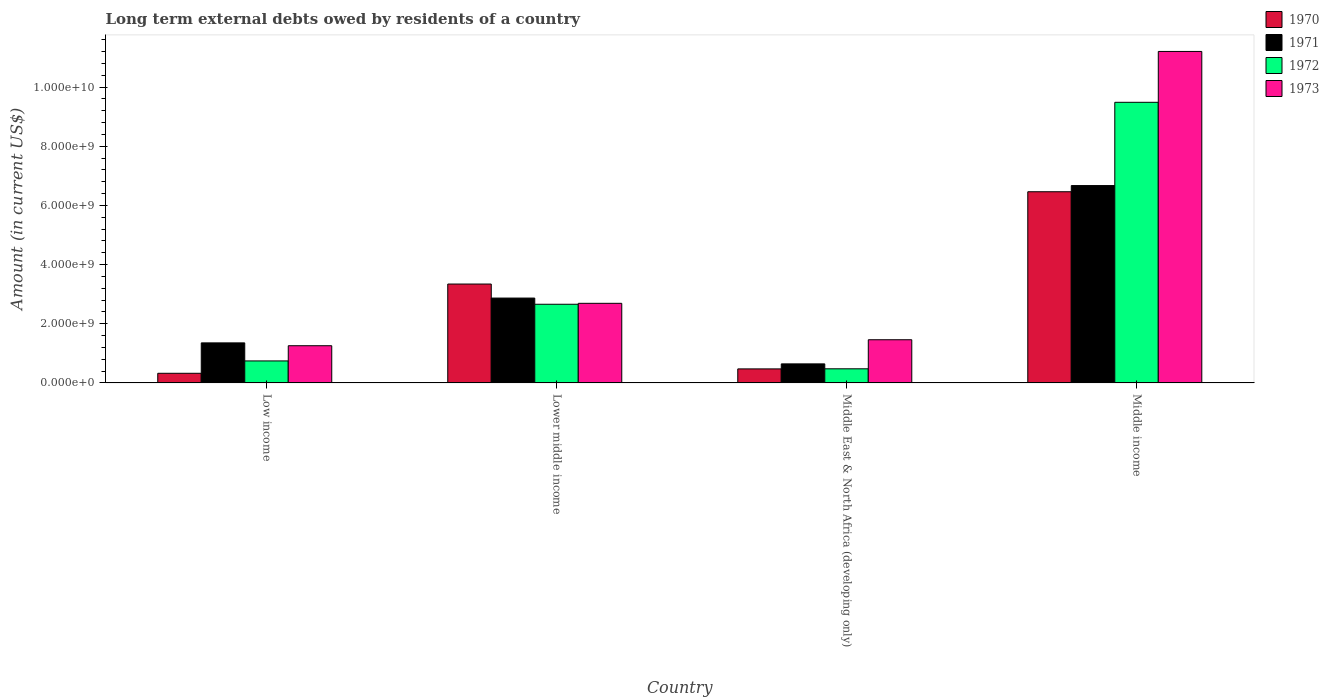Are the number of bars per tick equal to the number of legend labels?
Keep it short and to the point. Yes. Are the number of bars on each tick of the X-axis equal?
Keep it short and to the point. Yes. How many bars are there on the 4th tick from the left?
Make the answer very short. 4. How many bars are there on the 1st tick from the right?
Your answer should be compact. 4. What is the label of the 3rd group of bars from the left?
Ensure brevity in your answer.  Middle East & North Africa (developing only). What is the amount of long-term external debts owed by residents in 1970 in Middle East & North Africa (developing only)?
Provide a succinct answer. 4.75e+08. Across all countries, what is the maximum amount of long-term external debts owed by residents in 1970?
Your answer should be compact. 6.46e+09. Across all countries, what is the minimum amount of long-term external debts owed by residents in 1970?
Keep it short and to the point. 3.26e+08. In which country was the amount of long-term external debts owed by residents in 1970 maximum?
Your answer should be compact. Middle income. In which country was the amount of long-term external debts owed by residents in 1970 minimum?
Give a very brief answer. Low income. What is the total amount of long-term external debts owed by residents in 1972 in the graph?
Your answer should be compact. 1.34e+1. What is the difference between the amount of long-term external debts owed by residents in 1970 in Middle East & North Africa (developing only) and that in Middle income?
Offer a terse response. -5.99e+09. What is the difference between the amount of long-term external debts owed by residents in 1970 in Lower middle income and the amount of long-term external debts owed by residents in 1971 in Low income?
Give a very brief answer. 1.99e+09. What is the average amount of long-term external debts owed by residents in 1973 per country?
Offer a very short reply. 4.15e+09. What is the difference between the amount of long-term external debts owed by residents of/in 1973 and amount of long-term external debts owed by residents of/in 1971 in Low income?
Keep it short and to the point. -9.57e+07. What is the ratio of the amount of long-term external debts owed by residents in 1973 in Low income to that in Lower middle income?
Offer a terse response. 0.47. What is the difference between the highest and the second highest amount of long-term external debts owed by residents in 1972?
Your response must be concise. 6.82e+09. What is the difference between the highest and the lowest amount of long-term external debts owed by residents in 1973?
Make the answer very short. 9.94e+09. Is it the case that in every country, the sum of the amount of long-term external debts owed by residents in 1970 and amount of long-term external debts owed by residents in 1973 is greater than the sum of amount of long-term external debts owed by residents in 1972 and amount of long-term external debts owed by residents in 1971?
Offer a very short reply. No. What does the 2nd bar from the left in Middle income represents?
Provide a short and direct response. 1971. What does the 2nd bar from the right in Middle income represents?
Your answer should be compact. 1972. Does the graph contain grids?
Ensure brevity in your answer.  No. How are the legend labels stacked?
Provide a short and direct response. Vertical. What is the title of the graph?
Make the answer very short. Long term external debts owed by residents of a country. What is the Amount (in current US$) of 1970 in Low income?
Your answer should be very brief. 3.26e+08. What is the Amount (in current US$) in 1971 in Low income?
Keep it short and to the point. 1.35e+09. What is the Amount (in current US$) in 1972 in Low income?
Make the answer very short. 7.44e+08. What is the Amount (in current US$) in 1973 in Low income?
Ensure brevity in your answer.  1.26e+09. What is the Amount (in current US$) in 1970 in Lower middle income?
Offer a terse response. 3.34e+09. What is the Amount (in current US$) in 1971 in Lower middle income?
Your answer should be compact. 2.87e+09. What is the Amount (in current US$) in 1972 in Lower middle income?
Your answer should be compact. 2.66e+09. What is the Amount (in current US$) in 1973 in Lower middle income?
Your answer should be compact. 2.69e+09. What is the Amount (in current US$) in 1970 in Middle East & North Africa (developing only)?
Provide a succinct answer. 4.75e+08. What is the Amount (in current US$) in 1971 in Middle East & North Africa (developing only)?
Give a very brief answer. 6.44e+08. What is the Amount (in current US$) in 1972 in Middle East & North Africa (developing only)?
Your answer should be compact. 4.78e+08. What is the Amount (in current US$) of 1973 in Middle East & North Africa (developing only)?
Give a very brief answer. 1.46e+09. What is the Amount (in current US$) of 1970 in Middle income?
Provide a succinct answer. 6.46e+09. What is the Amount (in current US$) in 1971 in Middle income?
Keep it short and to the point. 6.67e+09. What is the Amount (in current US$) of 1972 in Middle income?
Offer a very short reply. 9.48e+09. What is the Amount (in current US$) in 1973 in Middle income?
Your answer should be very brief. 1.12e+1. Across all countries, what is the maximum Amount (in current US$) of 1970?
Offer a very short reply. 6.46e+09. Across all countries, what is the maximum Amount (in current US$) in 1971?
Your response must be concise. 6.67e+09. Across all countries, what is the maximum Amount (in current US$) of 1972?
Your answer should be compact. 9.48e+09. Across all countries, what is the maximum Amount (in current US$) in 1973?
Make the answer very short. 1.12e+1. Across all countries, what is the minimum Amount (in current US$) of 1970?
Give a very brief answer. 3.26e+08. Across all countries, what is the minimum Amount (in current US$) in 1971?
Offer a very short reply. 6.44e+08. Across all countries, what is the minimum Amount (in current US$) of 1972?
Ensure brevity in your answer.  4.78e+08. Across all countries, what is the minimum Amount (in current US$) of 1973?
Make the answer very short. 1.26e+09. What is the total Amount (in current US$) in 1970 in the graph?
Make the answer very short. 1.06e+1. What is the total Amount (in current US$) of 1971 in the graph?
Provide a succinct answer. 1.15e+1. What is the total Amount (in current US$) of 1972 in the graph?
Provide a succinct answer. 1.34e+1. What is the total Amount (in current US$) of 1973 in the graph?
Provide a short and direct response. 1.66e+1. What is the difference between the Amount (in current US$) of 1970 in Low income and that in Lower middle income?
Offer a very short reply. -3.02e+09. What is the difference between the Amount (in current US$) in 1971 in Low income and that in Lower middle income?
Offer a very short reply. -1.51e+09. What is the difference between the Amount (in current US$) of 1972 in Low income and that in Lower middle income?
Ensure brevity in your answer.  -1.91e+09. What is the difference between the Amount (in current US$) of 1973 in Low income and that in Lower middle income?
Keep it short and to the point. -1.43e+09. What is the difference between the Amount (in current US$) in 1970 in Low income and that in Middle East & North Africa (developing only)?
Ensure brevity in your answer.  -1.48e+08. What is the difference between the Amount (in current US$) of 1971 in Low income and that in Middle East & North Africa (developing only)?
Offer a terse response. 7.09e+08. What is the difference between the Amount (in current US$) of 1972 in Low income and that in Middle East & North Africa (developing only)?
Offer a terse response. 2.66e+08. What is the difference between the Amount (in current US$) in 1973 in Low income and that in Middle East & North Africa (developing only)?
Provide a short and direct response. -2.02e+08. What is the difference between the Amount (in current US$) of 1970 in Low income and that in Middle income?
Keep it short and to the point. -6.13e+09. What is the difference between the Amount (in current US$) of 1971 in Low income and that in Middle income?
Offer a very short reply. -5.32e+09. What is the difference between the Amount (in current US$) in 1972 in Low income and that in Middle income?
Give a very brief answer. -8.74e+09. What is the difference between the Amount (in current US$) of 1973 in Low income and that in Middle income?
Offer a very short reply. -9.94e+09. What is the difference between the Amount (in current US$) of 1970 in Lower middle income and that in Middle East & North Africa (developing only)?
Keep it short and to the point. 2.87e+09. What is the difference between the Amount (in current US$) of 1971 in Lower middle income and that in Middle East & North Africa (developing only)?
Provide a succinct answer. 2.22e+09. What is the difference between the Amount (in current US$) of 1972 in Lower middle income and that in Middle East & North Africa (developing only)?
Keep it short and to the point. 2.18e+09. What is the difference between the Amount (in current US$) in 1973 in Lower middle income and that in Middle East & North Africa (developing only)?
Your response must be concise. 1.23e+09. What is the difference between the Amount (in current US$) in 1970 in Lower middle income and that in Middle income?
Your response must be concise. -3.12e+09. What is the difference between the Amount (in current US$) in 1971 in Lower middle income and that in Middle income?
Make the answer very short. -3.80e+09. What is the difference between the Amount (in current US$) in 1972 in Lower middle income and that in Middle income?
Ensure brevity in your answer.  -6.82e+09. What is the difference between the Amount (in current US$) in 1973 in Lower middle income and that in Middle income?
Your response must be concise. -8.51e+09. What is the difference between the Amount (in current US$) in 1970 in Middle East & North Africa (developing only) and that in Middle income?
Offer a terse response. -5.99e+09. What is the difference between the Amount (in current US$) in 1971 in Middle East & North Africa (developing only) and that in Middle income?
Offer a terse response. -6.02e+09. What is the difference between the Amount (in current US$) in 1972 in Middle East & North Africa (developing only) and that in Middle income?
Make the answer very short. -9.01e+09. What is the difference between the Amount (in current US$) in 1973 in Middle East & North Africa (developing only) and that in Middle income?
Your answer should be compact. -9.74e+09. What is the difference between the Amount (in current US$) in 1970 in Low income and the Amount (in current US$) in 1971 in Lower middle income?
Ensure brevity in your answer.  -2.54e+09. What is the difference between the Amount (in current US$) in 1970 in Low income and the Amount (in current US$) in 1972 in Lower middle income?
Ensure brevity in your answer.  -2.33e+09. What is the difference between the Amount (in current US$) of 1970 in Low income and the Amount (in current US$) of 1973 in Lower middle income?
Your answer should be compact. -2.36e+09. What is the difference between the Amount (in current US$) in 1971 in Low income and the Amount (in current US$) in 1972 in Lower middle income?
Give a very brief answer. -1.31e+09. What is the difference between the Amount (in current US$) of 1971 in Low income and the Amount (in current US$) of 1973 in Lower middle income?
Offer a terse response. -1.34e+09. What is the difference between the Amount (in current US$) of 1972 in Low income and the Amount (in current US$) of 1973 in Lower middle income?
Make the answer very short. -1.95e+09. What is the difference between the Amount (in current US$) in 1970 in Low income and the Amount (in current US$) in 1971 in Middle East & North Africa (developing only)?
Provide a short and direct response. -3.18e+08. What is the difference between the Amount (in current US$) of 1970 in Low income and the Amount (in current US$) of 1972 in Middle East & North Africa (developing only)?
Your response must be concise. -1.52e+08. What is the difference between the Amount (in current US$) of 1970 in Low income and the Amount (in current US$) of 1973 in Middle East & North Africa (developing only)?
Provide a succinct answer. -1.13e+09. What is the difference between the Amount (in current US$) in 1971 in Low income and the Amount (in current US$) in 1972 in Middle East & North Africa (developing only)?
Give a very brief answer. 8.76e+08. What is the difference between the Amount (in current US$) in 1971 in Low income and the Amount (in current US$) in 1973 in Middle East & North Africa (developing only)?
Your response must be concise. -1.06e+08. What is the difference between the Amount (in current US$) of 1972 in Low income and the Amount (in current US$) of 1973 in Middle East & North Africa (developing only)?
Make the answer very short. -7.16e+08. What is the difference between the Amount (in current US$) in 1970 in Low income and the Amount (in current US$) in 1971 in Middle income?
Provide a succinct answer. -6.34e+09. What is the difference between the Amount (in current US$) of 1970 in Low income and the Amount (in current US$) of 1972 in Middle income?
Give a very brief answer. -9.16e+09. What is the difference between the Amount (in current US$) in 1970 in Low income and the Amount (in current US$) in 1973 in Middle income?
Keep it short and to the point. -1.09e+1. What is the difference between the Amount (in current US$) of 1971 in Low income and the Amount (in current US$) of 1972 in Middle income?
Give a very brief answer. -8.13e+09. What is the difference between the Amount (in current US$) in 1971 in Low income and the Amount (in current US$) in 1973 in Middle income?
Provide a succinct answer. -9.85e+09. What is the difference between the Amount (in current US$) of 1972 in Low income and the Amount (in current US$) of 1973 in Middle income?
Keep it short and to the point. -1.05e+1. What is the difference between the Amount (in current US$) of 1970 in Lower middle income and the Amount (in current US$) of 1971 in Middle East & North Africa (developing only)?
Provide a short and direct response. 2.70e+09. What is the difference between the Amount (in current US$) in 1970 in Lower middle income and the Amount (in current US$) in 1972 in Middle East & North Africa (developing only)?
Give a very brief answer. 2.86e+09. What is the difference between the Amount (in current US$) in 1970 in Lower middle income and the Amount (in current US$) in 1973 in Middle East & North Africa (developing only)?
Your answer should be compact. 1.88e+09. What is the difference between the Amount (in current US$) of 1971 in Lower middle income and the Amount (in current US$) of 1972 in Middle East & North Africa (developing only)?
Provide a short and direct response. 2.39e+09. What is the difference between the Amount (in current US$) in 1971 in Lower middle income and the Amount (in current US$) in 1973 in Middle East & North Africa (developing only)?
Your response must be concise. 1.41e+09. What is the difference between the Amount (in current US$) of 1972 in Lower middle income and the Amount (in current US$) of 1973 in Middle East & North Africa (developing only)?
Your response must be concise. 1.20e+09. What is the difference between the Amount (in current US$) of 1970 in Lower middle income and the Amount (in current US$) of 1971 in Middle income?
Offer a very short reply. -3.33e+09. What is the difference between the Amount (in current US$) of 1970 in Lower middle income and the Amount (in current US$) of 1972 in Middle income?
Ensure brevity in your answer.  -6.14e+09. What is the difference between the Amount (in current US$) in 1970 in Lower middle income and the Amount (in current US$) in 1973 in Middle income?
Your answer should be compact. -7.86e+09. What is the difference between the Amount (in current US$) in 1971 in Lower middle income and the Amount (in current US$) in 1972 in Middle income?
Offer a terse response. -6.62e+09. What is the difference between the Amount (in current US$) of 1971 in Lower middle income and the Amount (in current US$) of 1973 in Middle income?
Your answer should be very brief. -8.33e+09. What is the difference between the Amount (in current US$) of 1972 in Lower middle income and the Amount (in current US$) of 1973 in Middle income?
Your answer should be compact. -8.54e+09. What is the difference between the Amount (in current US$) of 1970 in Middle East & North Africa (developing only) and the Amount (in current US$) of 1971 in Middle income?
Offer a very short reply. -6.19e+09. What is the difference between the Amount (in current US$) of 1970 in Middle East & North Africa (developing only) and the Amount (in current US$) of 1972 in Middle income?
Keep it short and to the point. -9.01e+09. What is the difference between the Amount (in current US$) of 1970 in Middle East & North Africa (developing only) and the Amount (in current US$) of 1973 in Middle income?
Ensure brevity in your answer.  -1.07e+1. What is the difference between the Amount (in current US$) of 1971 in Middle East & North Africa (developing only) and the Amount (in current US$) of 1972 in Middle income?
Ensure brevity in your answer.  -8.84e+09. What is the difference between the Amount (in current US$) in 1971 in Middle East & North Africa (developing only) and the Amount (in current US$) in 1973 in Middle income?
Your answer should be compact. -1.06e+1. What is the difference between the Amount (in current US$) in 1972 in Middle East & North Africa (developing only) and the Amount (in current US$) in 1973 in Middle income?
Your answer should be compact. -1.07e+1. What is the average Amount (in current US$) in 1970 per country?
Ensure brevity in your answer.  2.65e+09. What is the average Amount (in current US$) in 1971 per country?
Offer a terse response. 2.88e+09. What is the average Amount (in current US$) of 1972 per country?
Offer a very short reply. 3.34e+09. What is the average Amount (in current US$) of 1973 per country?
Provide a short and direct response. 4.15e+09. What is the difference between the Amount (in current US$) of 1970 and Amount (in current US$) of 1971 in Low income?
Give a very brief answer. -1.03e+09. What is the difference between the Amount (in current US$) in 1970 and Amount (in current US$) in 1972 in Low income?
Your answer should be very brief. -4.17e+08. What is the difference between the Amount (in current US$) of 1970 and Amount (in current US$) of 1973 in Low income?
Provide a succinct answer. -9.31e+08. What is the difference between the Amount (in current US$) of 1971 and Amount (in current US$) of 1972 in Low income?
Keep it short and to the point. 6.10e+08. What is the difference between the Amount (in current US$) of 1971 and Amount (in current US$) of 1973 in Low income?
Offer a terse response. 9.57e+07. What is the difference between the Amount (in current US$) in 1972 and Amount (in current US$) in 1973 in Low income?
Your answer should be compact. -5.14e+08. What is the difference between the Amount (in current US$) in 1970 and Amount (in current US$) in 1971 in Lower middle income?
Provide a succinct answer. 4.74e+08. What is the difference between the Amount (in current US$) of 1970 and Amount (in current US$) of 1972 in Lower middle income?
Provide a short and direct response. 6.83e+08. What is the difference between the Amount (in current US$) of 1970 and Amount (in current US$) of 1973 in Lower middle income?
Give a very brief answer. 6.52e+08. What is the difference between the Amount (in current US$) in 1971 and Amount (in current US$) in 1972 in Lower middle income?
Provide a short and direct response. 2.09e+08. What is the difference between the Amount (in current US$) of 1971 and Amount (in current US$) of 1973 in Lower middle income?
Your answer should be compact. 1.77e+08. What is the difference between the Amount (in current US$) in 1972 and Amount (in current US$) in 1973 in Lower middle income?
Keep it short and to the point. -3.18e+07. What is the difference between the Amount (in current US$) in 1970 and Amount (in current US$) in 1971 in Middle East & North Africa (developing only)?
Keep it short and to the point. -1.70e+08. What is the difference between the Amount (in current US$) of 1970 and Amount (in current US$) of 1972 in Middle East & North Africa (developing only)?
Your answer should be compact. -3.25e+06. What is the difference between the Amount (in current US$) in 1970 and Amount (in current US$) in 1973 in Middle East & North Africa (developing only)?
Your answer should be compact. -9.85e+08. What is the difference between the Amount (in current US$) of 1971 and Amount (in current US$) of 1972 in Middle East & North Africa (developing only)?
Give a very brief answer. 1.66e+08. What is the difference between the Amount (in current US$) of 1971 and Amount (in current US$) of 1973 in Middle East & North Africa (developing only)?
Give a very brief answer. -8.15e+08. What is the difference between the Amount (in current US$) of 1972 and Amount (in current US$) of 1973 in Middle East & North Africa (developing only)?
Offer a very short reply. -9.82e+08. What is the difference between the Amount (in current US$) of 1970 and Amount (in current US$) of 1971 in Middle income?
Your answer should be very brief. -2.08e+08. What is the difference between the Amount (in current US$) in 1970 and Amount (in current US$) in 1972 in Middle income?
Make the answer very short. -3.02e+09. What is the difference between the Amount (in current US$) in 1970 and Amount (in current US$) in 1973 in Middle income?
Your answer should be compact. -4.74e+09. What is the difference between the Amount (in current US$) in 1971 and Amount (in current US$) in 1972 in Middle income?
Your response must be concise. -2.81e+09. What is the difference between the Amount (in current US$) of 1971 and Amount (in current US$) of 1973 in Middle income?
Make the answer very short. -4.53e+09. What is the difference between the Amount (in current US$) of 1972 and Amount (in current US$) of 1973 in Middle income?
Offer a very short reply. -1.72e+09. What is the ratio of the Amount (in current US$) of 1970 in Low income to that in Lower middle income?
Your answer should be very brief. 0.1. What is the ratio of the Amount (in current US$) in 1971 in Low income to that in Lower middle income?
Your response must be concise. 0.47. What is the ratio of the Amount (in current US$) of 1972 in Low income to that in Lower middle income?
Your answer should be very brief. 0.28. What is the ratio of the Amount (in current US$) of 1973 in Low income to that in Lower middle income?
Make the answer very short. 0.47. What is the ratio of the Amount (in current US$) in 1970 in Low income to that in Middle East & North Africa (developing only)?
Give a very brief answer. 0.69. What is the ratio of the Amount (in current US$) of 1971 in Low income to that in Middle East & North Africa (developing only)?
Your answer should be compact. 2.1. What is the ratio of the Amount (in current US$) in 1972 in Low income to that in Middle East & North Africa (developing only)?
Your response must be concise. 1.56. What is the ratio of the Amount (in current US$) in 1973 in Low income to that in Middle East & North Africa (developing only)?
Your answer should be very brief. 0.86. What is the ratio of the Amount (in current US$) of 1970 in Low income to that in Middle income?
Keep it short and to the point. 0.05. What is the ratio of the Amount (in current US$) of 1971 in Low income to that in Middle income?
Give a very brief answer. 0.2. What is the ratio of the Amount (in current US$) in 1972 in Low income to that in Middle income?
Provide a short and direct response. 0.08. What is the ratio of the Amount (in current US$) in 1973 in Low income to that in Middle income?
Make the answer very short. 0.11. What is the ratio of the Amount (in current US$) of 1970 in Lower middle income to that in Middle East & North Africa (developing only)?
Provide a short and direct response. 7.04. What is the ratio of the Amount (in current US$) of 1971 in Lower middle income to that in Middle East & North Africa (developing only)?
Ensure brevity in your answer.  4.45. What is the ratio of the Amount (in current US$) in 1972 in Lower middle income to that in Middle East & North Africa (developing only)?
Give a very brief answer. 5.56. What is the ratio of the Amount (in current US$) in 1973 in Lower middle income to that in Middle East & North Africa (developing only)?
Provide a succinct answer. 1.84. What is the ratio of the Amount (in current US$) in 1970 in Lower middle income to that in Middle income?
Make the answer very short. 0.52. What is the ratio of the Amount (in current US$) of 1971 in Lower middle income to that in Middle income?
Your answer should be very brief. 0.43. What is the ratio of the Amount (in current US$) in 1972 in Lower middle income to that in Middle income?
Your answer should be compact. 0.28. What is the ratio of the Amount (in current US$) in 1973 in Lower middle income to that in Middle income?
Your answer should be very brief. 0.24. What is the ratio of the Amount (in current US$) of 1970 in Middle East & North Africa (developing only) to that in Middle income?
Keep it short and to the point. 0.07. What is the ratio of the Amount (in current US$) of 1971 in Middle East & North Africa (developing only) to that in Middle income?
Offer a terse response. 0.1. What is the ratio of the Amount (in current US$) in 1972 in Middle East & North Africa (developing only) to that in Middle income?
Offer a terse response. 0.05. What is the ratio of the Amount (in current US$) in 1973 in Middle East & North Africa (developing only) to that in Middle income?
Provide a succinct answer. 0.13. What is the difference between the highest and the second highest Amount (in current US$) of 1970?
Give a very brief answer. 3.12e+09. What is the difference between the highest and the second highest Amount (in current US$) of 1971?
Provide a short and direct response. 3.80e+09. What is the difference between the highest and the second highest Amount (in current US$) of 1972?
Give a very brief answer. 6.82e+09. What is the difference between the highest and the second highest Amount (in current US$) in 1973?
Offer a terse response. 8.51e+09. What is the difference between the highest and the lowest Amount (in current US$) of 1970?
Offer a very short reply. 6.13e+09. What is the difference between the highest and the lowest Amount (in current US$) in 1971?
Keep it short and to the point. 6.02e+09. What is the difference between the highest and the lowest Amount (in current US$) of 1972?
Offer a very short reply. 9.01e+09. What is the difference between the highest and the lowest Amount (in current US$) in 1973?
Offer a very short reply. 9.94e+09. 